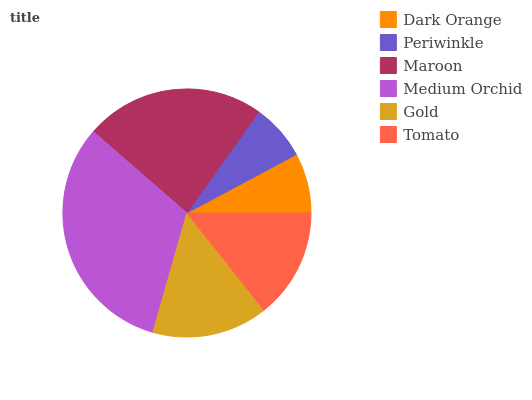Is Periwinkle the minimum?
Answer yes or no. Yes. Is Medium Orchid the maximum?
Answer yes or no. Yes. Is Maroon the minimum?
Answer yes or no. No. Is Maroon the maximum?
Answer yes or no. No. Is Maroon greater than Periwinkle?
Answer yes or no. Yes. Is Periwinkle less than Maroon?
Answer yes or no. Yes. Is Periwinkle greater than Maroon?
Answer yes or no. No. Is Maroon less than Periwinkle?
Answer yes or no. No. Is Gold the high median?
Answer yes or no. Yes. Is Tomato the low median?
Answer yes or no. Yes. Is Dark Orange the high median?
Answer yes or no. No. Is Dark Orange the low median?
Answer yes or no. No. 